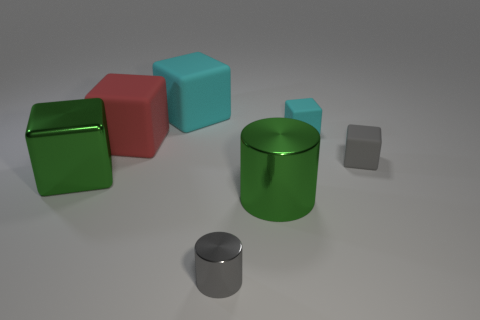Does the large shiny cylinder have the same color as the object to the left of the red object?
Make the answer very short. Yes. The other object that is the same color as the tiny metal thing is what size?
Offer a very short reply. Small. Are there the same number of big green metallic blocks that are to the right of the big green cylinder and small cyan rubber objects to the right of the big red rubber cube?
Your answer should be compact. No. What number of other big things have the same shape as the gray shiny object?
Keep it short and to the point. 1. Is there a small cylinder made of the same material as the green block?
Keep it short and to the point. Yes. The thing that is the same color as the big shiny cube is what shape?
Your response must be concise. Cylinder. How many matte things are there?
Ensure brevity in your answer.  4. What number of balls are either small rubber objects or red objects?
Ensure brevity in your answer.  0. What color is the shiny cylinder that is the same size as the red object?
Ensure brevity in your answer.  Green. How many cyan objects are right of the green metal cylinder and on the left side of the tiny metallic cylinder?
Offer a terse response. 0. 